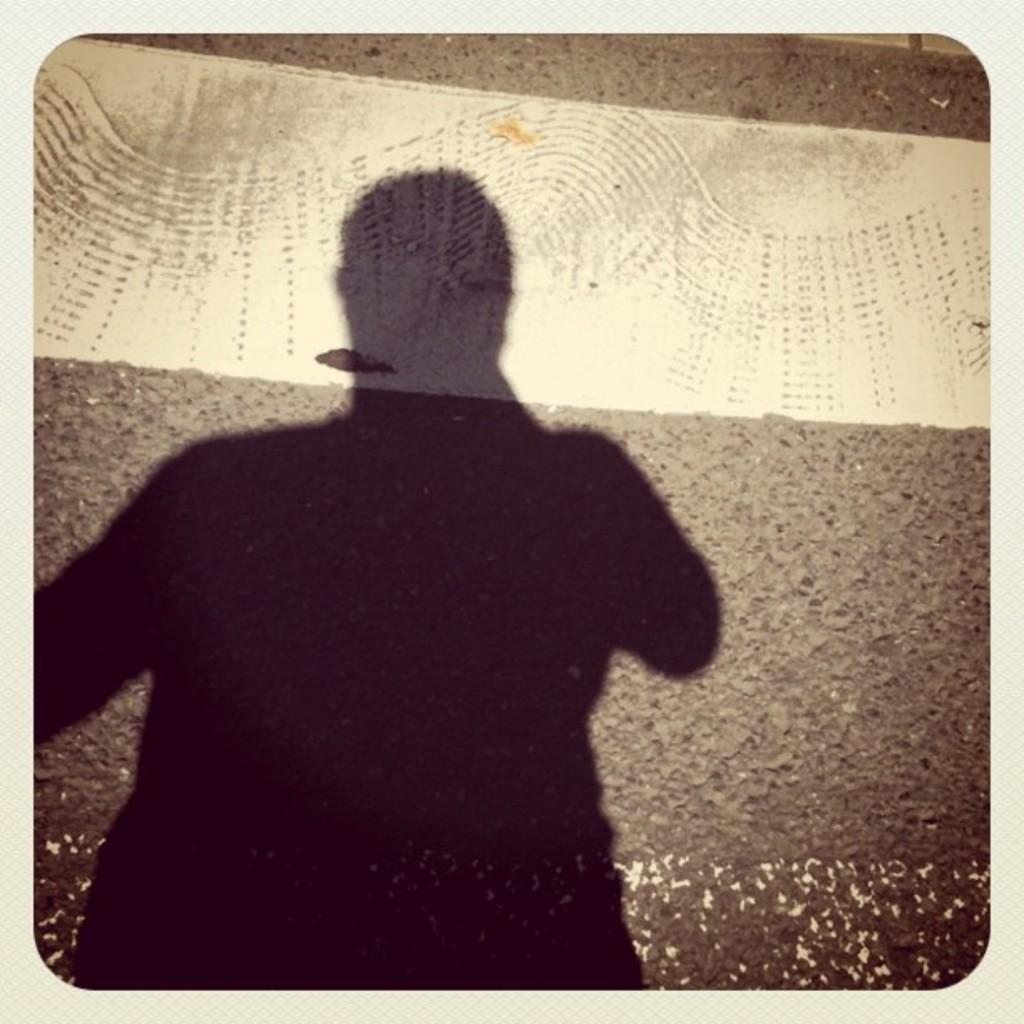What can be seen on the left side of the image? There is a person's shadow on the left side of the image. What is visible in the background of the image? There is a road visible in the background of the image. Can you see a copy of the person's shadow on the right side of the image? There is no copy of the person's shadow on the right side of the image; only one shadow is present on the left side. What type of feather is visible in the image? There are no feathers present in the image. 